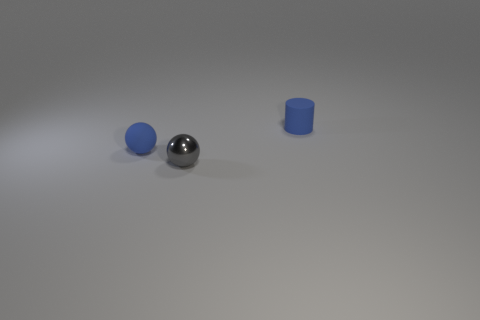What number of objects are either small gray blocks or tiny blue balls? In the image, there are a total of three objects present, but among these objects we can identify one small gray block and no tiny blue balls, resulting in a count of one for the objects that match the criteria specified. 